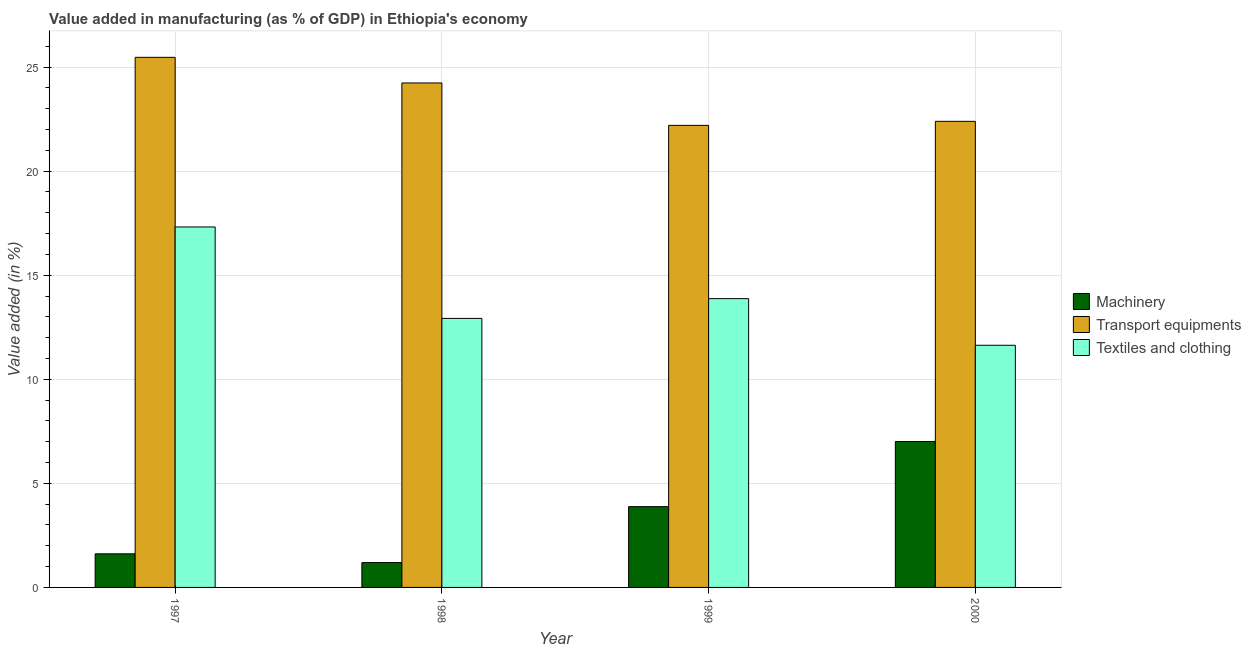How many groups of bars are there?
Your answer should be very brief. 4. Are the number of bars per tick equal to the number of legend labels?
Offer a terse response. Yes. Are the number of bars on each tick of the X-axis equal?
Your response must be concise. Yes. In how many cases, is the number of bars for a given year not equal to the number of legend labels?
Ensure brevity in your answer.  0. What is the value added in manufacturing machinery in 1999?
Your response must be concise. 3.88. Across all years, what is the maximum value added in manufacturing transport equipments?
Ensure brevity in your answer.  25.47. Across all years, what is the minimum value added in manufacturing machinery?
Provide a succinct answer. 1.19. In which year was the value added in manufacturing machinery minimum?
Offer a terse response. 1998. What is the total value added in manufacturing machinery in the graph?
Your answer should be very brief. 13.7. What is the difference between the value added in manufacturing textile and clothing in 1998 and that in 1999?
Provide a short and direct response. -0.95. What is the difference between the value added in manufacturing machinery in 1997 and the value added in manufacturing transport equipments in 1998?
Provide a succinct answer. 0.42. What is the average value added in manufacturing machinery per year?
Provide a short and direct response. 3.43. In the year 1999, what is the difference between the value added in manufacturing machinery and value added in manufacturing transport equipments?
Your answer should be compact. 0. In how many years, is the value added in manufacturing textile and clothing greater than 19 %?
Provide a succinct answer. 0. What is the ratio of the value added in manufacturing machinery in 1998 to that in 1999?
Your answer should be very brief. 0.31. Is the value added in manufacturing machinery in 1997 less than that in 1999?
Ensure brevity in your answer.  Yes. What is the difference between the highest and the second highest value added in manufacturing textile and clothing?
Your answer should be compact. 3.44. What is the difference between the highest and the lowest value added in manufacturing transport equipments?
Make the answer very short. 3.27. Is the sum of the value added in manufacturing textile and clothing in 1997 and 2000 greater than the maximum value added in manufacturing machinery across all years?
Your answer should be very brief. Yes. What does the 2nd bar from the left in 2000 represents?
Offer a very short reply. Transport equipments. What does the 1st bar from the right in 1997 represents?
Your answer should be compact. Textiles and clothing. Is it the case that in every year, the sum of the value added in manufacturing machinery and value added in manufacturing transport equipments is greater than the value added in manufacturing textile and clothing?
Ensure brevity in your answer.  Yes. How many years are there in the graph?
Your answer should be compact. 4. Does the graph contain any zero values?
Provide a short and direct response. No. What is the title of the graph?
Provide a succinct answer. Value added in manufacturing (as % of GDP) in Ethiopia's economy. What is the label or title of the Y-axis?
Offer a terse response. Value added (in %). What is the Value added (in %) of Machinery in 1997?
Give a very brief answer. 1.61. What is the Value added (in %) of Transport equipments in 1997?
Offer a terse response. 25.47. What is the Value added (in %) in Textiles and clothing in 1997?
Your answer should be very brief. 17.32. What is the Value added (in %) in Machinery in 1998?
Provide a short and direct response. 1.19. What is the Value added (in %) of Transport equipments in 1998?
Your answer should be very brief. 24.24. What is the Value added (in %) in Textiles and clothing in 1998?
Your answer should be compact. 12.93. What is the Value added (in %) in Machinery in 1999?
Keep it short and to the point. 3.88. What is the Value added (in %) in Transport equipments in 1999?
Keep it short and to the point. 22.2. What is the Value added (in %) in Textiles and clothing in 1999?
Keep it short and to the point. 13.88. What is the Value added (in %) in Machinery in 2000?
Keep it short and to the point. 7.01. What is the Value added (in %) in Transport equipments in 2000?
Give a very brief answer. 22.39. What is the Value added (in %) of Textiles and clothing in 2000?
Give a very brief answer. 11.63. Across all years, what is the maximum Value added (in %) of Machinery?
Your answer should be very brief. 7.01. Across all years, what is the maximum Value added (in %) in Transport equipments?
Your answer should be very brief. 25.47. Across all years, what is the maximum Value added (in %) in Textiles and clothing?
Offer a very short reply. 17.32. Across all years, what is the minimum Value added (in %) in Machinery?
Provide a short and direct response. 1.19. Across all years, what is the minimum Value added (in %) of Transport equipments?
Your response must be concise. 22.2. Across all years, what is the minimum Value added (in %) in Textiles and clothing?
Provide a succinct answer. 11.63. What is the total Value added (in %) of Machinery in the graph?
Ensure brevity in your answer.  13.7. What is the total Value added (in %) in Transport equipments in the graph?
Provide a succinct answer. 94.3. What is the total Value added (in %) of Textiles and clothing in the graph?
Provide a succinct answer. 55.75. What is the difference between the Value added (in %) in Machinery in 1997 and that in 1998?
Ensure brevity in your answer.  0.42. What is the difference between the Value added (in %) of Transport equipments in 1997 and that in 1998?
Offer a very short reply. 1.23. What is the difference between the Value added (in %) of Textiles and clothing in 1997 and that in 1998?
Provide a succinct answer. 4.39. What is the difference between the Value added (in %) of Machinery in 1997 and that in 1999?
Keep it short and to the point. -2.27. What is the difference between the Value added (in %) of Transport equipments in 1997 and that in 1999?
Offer a terse response. 3.27. What is the difference between the Value added (in %) of Textiles and clothing in 1997 and that in 1999?
Make the answer very short. 3.44. What is the difference between the Value added (in %) in Machinery in 1997 and that in 2000?
Provide a short and direct response. -5.4. What is the difference between the Value added (in %) of Transport equipments in 1997 and that in 2000?
Offer a terse response. 3.07. What is the difference between the Value added (in %) in Textiles and clothing in 1997 and that in 2000?
Keep it short and to the point. 5.68. What is the difference between the Value added (in %) of Machinery in 1998 and that in 1999?
Your answer should be compact. -2.69. What is the difference between the Value added (in %) of Transport equipments in 1998 and that in 1999?
Your answer should be compact. 2.04. What is the difference between the Value added (in %) of Textiles and clothing in 1998 and that in 1999?
Make the answer very short. -0.95. What is the difference between the Value added (in %) in Machinery in 1998 and that in 2000?
Keep it short and to the point. -5.82. What is the difference between the Value added (in %) of Transport equipments in 1998 and that in 2000?
Offer a terse response. 1.84. What is the difference between the Value added (in %) of Textiles and clothing in 1998 and that in 2000?
Keep it short and to the point. 1.29. What is the difference between the Value added (in %) of Machinery in 1999 and that in 2000?
Ensure brevity in your answer.  -3.13. What is the difference between the Value added (in %) of Transport equipments in 1999 and that in 2000?
Offer a very short reply. -0.19. What is the difference between the Value added (in %) in Textiles and clothing in 1999 and that in 2000?
Provide a succinct answer. 2.24. What is the difference between the Value added (in %) of Machinery in 1997 and the Value added (in %) of Transport equipments in 1998?
Provide a succinct answer. -22.62. What is the difference between the Value added (in %) of Machinery in 1997 and the Value added (in %) of Textiles and clothing in 1998?
Provide a succinct answer. -11.31. What is the difference between the Value added (in %) of Transport equipments in 1997 and the Value added (in %) of Textiles and clothing in 1998?
Keep it short and to the point. 12.54. What is the difference between the Value added (in %) of Machinery in 1997 and the Value added (in %) of Transport equipments in 1999?
Your answer should be compact. -20.59. What is the difference between the Value added (in %) of Machinery in 1997 and the Value added (in %) of Textiles and clothing in 1999?
Provide a succinct answer. -12.26. What is the difference between the Value added (in %) in Transport equipments in 1997 and the Value added (in %) in Textiles and clothing in 1999?
Your answer should be compact. 11.59. What is the difference between the Value added (in %) in Machinery in 1997 and the Value added (in %) in Transport equipments in 2000?
Your response must be concise. -20.78. What is the difference between the Value added (in %) of Machinery in 1997 and the Value added (in %) of Textiles and clothing in 2000?
Provide a short and direct response. -10.02. What is the difference between the Value added (in %) in Transport equipments in 1997 and the Value added (in %) in Textiles and clothing in 2000?
Provide a short and direct response. 13.83. What is the difference between the Value added (in %) in Machinery in 1998 and the Value added (in %) in Transport equipments in 1999?
Offer a terse response. -21.01. What is the difference between the Value added (in %) in Machinery in 1998 and the Value added (in %) in Textiles and clothing in 1999?
Keep it short and to the point. -12.68. What is the difference between the Value added (in %) in Transport equipments in 1998 and the Value added (in %) in Textiles and clothing in 1999?
Your answer should be very brief. 10.36. What is the difference between the Value added (in %) of Machinery in 1998 and the Value added (in %) of Transport equipments in 2000?
Your answer should be compact. -21.2. What is the difference between the Value added (in %) of Machinery in 1998 and the Value added (in %) of Textiles and clothing in 2000?
Offer a terse response. -10.44. What is the difference between the Value added (in %) in Transport equipments in 1998 and the Value added (in %) in Textiles and clothing in 2000?
Your answer should be compact. 12.6. What is the difference between the Value added (in %) of Machinery in 1999 and the Value added (in %) of Transport equipments in 2000?
Provide a short and direct response. -18.51. What is the difference between the Value added (in %) of Machinery in 1999 and the Value added (in %) of Textiles and clothing in 2000?
Provide a succinct answer. -7.75. What is the difference between the Value added (in %) of Transport equipments in 1999 and the Value added (in %) of Textiles and clothing in 2000?
Your answer should be compact. 10.57. What is the average Value added (in %) in Machinery per year?
Make the answer very short. 3.43. What is the average Value added (in %) of Transport equipments per year?
Your response must be concise. 23.58. What is the average Value added (in %) in Textiles and clothing per year?
Give a very brief answer. 13.94. In the year 1997, what is the difference between the Value added (in %) in Machinery and Value added (in %) in Transport equipments?
Keep it short and to the point. -23.85. In the year 1997, what is the difference between the Value added (in %) of Machinery and Value added (in %) of Textiles and clothing?
Your answer should be very brief. -15.7. In the year 1997, what is the difference between the Value added (in %) of Transport equipments and Value added (in %) of Textiles and clothing?
Offer a terse response. 8.15. In the year 1998, what is the difference between the Value added (in %) in Machinery and Value added (in %) in Transport equipments?
Provide a succinct answer. -23.04. In the year 1998, what is the difference between the Value added (in %) of Machinery and Value added (in %) of Textiles and clothing?
Make the answer very short. -11.73. In the year 1998, what is the difference between the Value added (in %) in Transport equipments and Value added (in %) in Textiles and clothing?
Provide a short and direct response. 11.31. In the year 1999, what is the difference between the Value added (in %) in Machinery and Value added (in %) in Transport equipments?
Keep it short and to the point. -18.32. In the year 1999, what is the difference between the Value added (in %) of Machinery and Value added (in %) of Textiles and clothing?
Offer a very short reply. -9.99. In the year 1999, what is the difference between the Value added (in %) in Transport equipments and Value added (in %) in Textiles and clothing?
Keep it short and to the point. 8.32. In the year 2000, what is the difference between the Value added (in %) of Machinery and Value added (in %) of Transport equipments?
Provide a succinct answer. -15.38. In the year 2000, what is the difference between the Value added (in %) in Machinery and Value added (in %) in Textiles and clothing?
Your answer should be very brief. -4.62. In the year 2000, what is the difference between the Value added (in %) of Transport equipments and Value added (in %) of Textiles and clothing?
Offer a terse response. 10.76. What is the ratio of the Value added (in %) of Machinery in 1997 to that in 1998?
Offer a terse response. 1.35. What is the ratio of the Value added (in %) of Transport equipments in 1997 to that in 1998?
Your answer should be compact. 1.05. What is the ratio of the Value added (in %) in Textiles and clothing in 1997 to that in 1998?
Give a very brief answer. 1.34. What is the ratio of the Value added (in %) of Machinery in 1997 to that in 1999?
Your response must be concise. 0.42. What is the ratio of the Value added (in %) in Transport equipments in 1997 to that in 1999?
Your answer should be very brief. 1.15. What is the ratio of the Value added (in %) in Textiles and clothing in 1997 to that in 1999?
Your answer should be compact. 1.25. What is the ratio of the Value added (in %) of Machinery in 1997 to that in 2000?
Provide a succinct answer. 0.23. What is the ratio of the Value added (in %) in Transport equipments in 1997 to that in 2000?
Provide a short and direct response. 1.14. What is the ratio of the Value added (in %) of Textiles and clothing in 1997 to that in 2000?
Your answer should be very brief. 1.49. What is the ratio of the Value added (in %) in Machinery in 1998 to that in 1999?
Ensure brevity in your answer.  0.31. What is the ratio of the Value added (in %) in Transport equipments in 1998 to that in 1999?
Provide a short and direct response. 1.09. What is the ratio of the Value added (in %) in Textiles and clothing in 1998 to that in 1999?
Provide a succinct answer. 0.93. What is the ratio of the Value added (in %) of Machinery in 1998 to that in 2000?
Make the answer very short. 0.17. What is the ratio of the Value added (in %) in Transport equipments in 1998 to that in 2000?
Offer a very short reply. 1.08. What is the ratio of the Value added (in %) in Textiles and clothing in 1998 to that in 2000?
Your answer should be compact. 1.11. What is the ratio of the Value added (in %) of Machinery in 1999 to that in 2000?
Offer a very short reply. 0.55. What is the ratio of the Value added (in %) of Textiles and clothing in 1999 to that in 2000?
Your response must be concise. 1.19. What is the difference between the highest and the second highest Value added (in %) in Machinery?
Your response must be concise. 3.13. What is the difference between the highest and the second highest Value added (in %) of Transport equipments?
Provide a succinct answer. 1.23. What is the difference between the highest and the second highest Value added (in %) in Textiles and clothing?
Offer a very short reply. 3.44. What is the difference between the highest and the lowest Value added (in %) of Machinery?
Make the answer very short. 5.82. What is the difference between the highest and the lowest Value added (in %) of Transport equipments?
Provide a short and direct response. 3.27. What is the difference between the highest and the lowest Value added (in %) in Textiles and clothing?
Give a very brief answer. 5.68. 